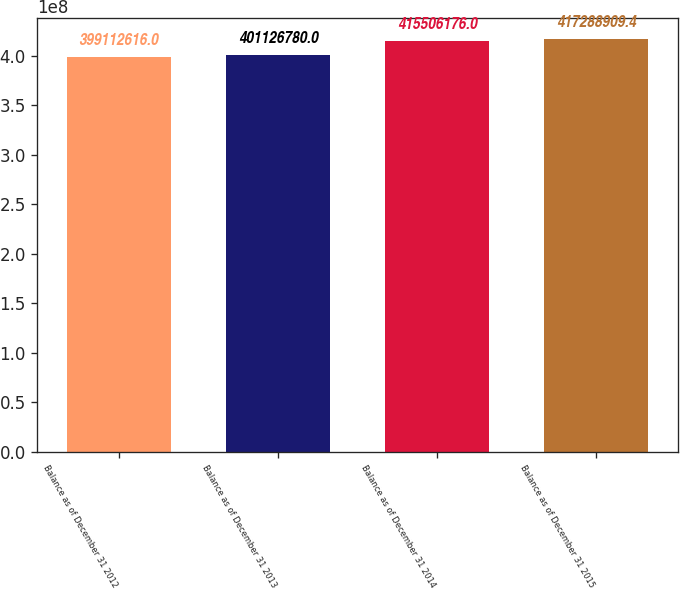Convert chart to OTSL. <chart><loc_0><loc_0><loc_500><loc_500><bar_chart><fcel>Balance as of December 31 2012<fcel>Balance as of December 31 2013<fcel>Balance as of December 31 2014<fcel>Balance as of December 31 2015<nl><fcel>3.99113e+08<fcel>4.01127e+08<fcel>4.15506e+08<fcel>4.17289e+08<nl></chart> 